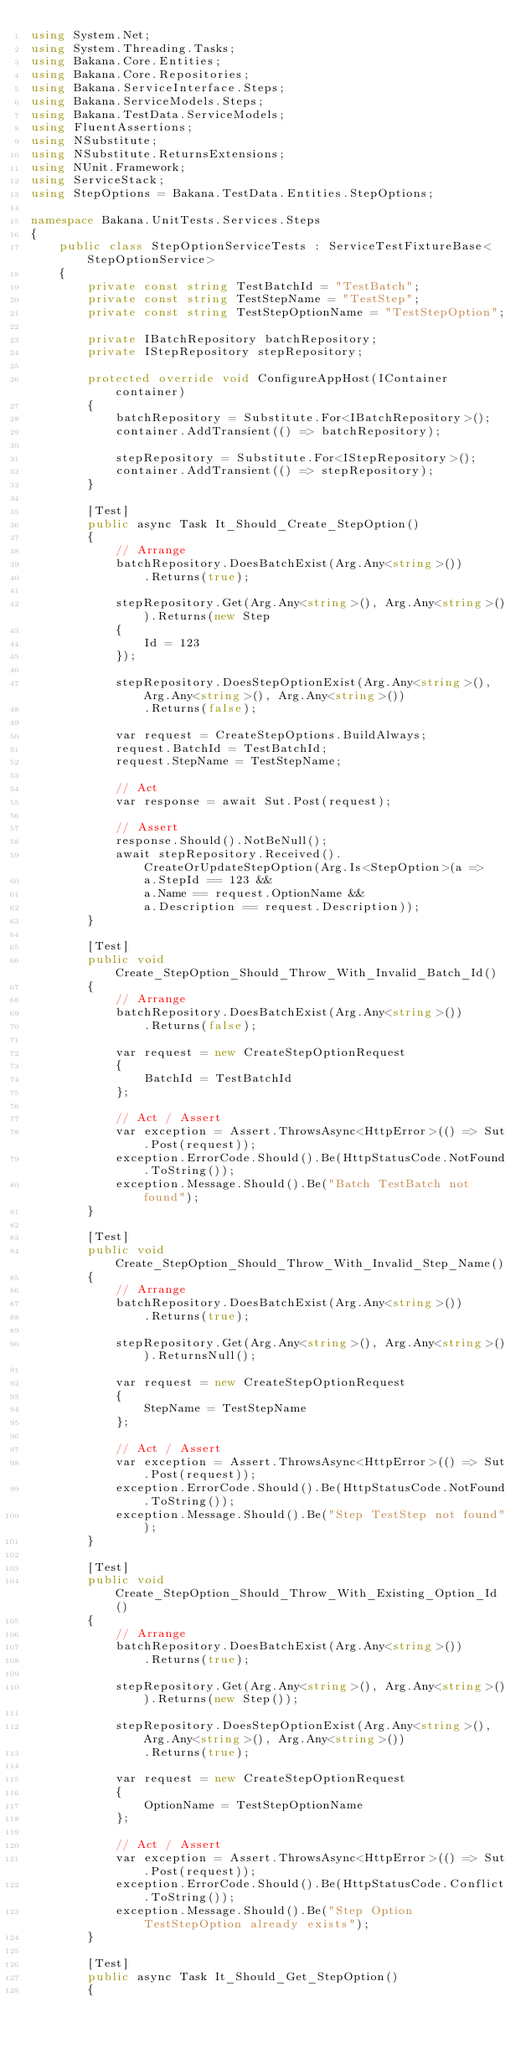Convert code to text. <code><loc_0><loc_0><loc_500><loc_500><_C#_>using System.Net;
using System.Threading.Tasks;
using Bakana.Core.Entities;
using Bakana.Core.Repositories;
using Bakana.ServiceInterface.Steps;
using Bakana.ServiceModels.Steps;
using Bakana.TestData.ServiceModels;
using FluentAssertions;
using NSubstitute;
using NSubstitute.ReturnsExtensions;
using NUnit.Framework;
using ServiceStack;
using StepOptions = Bakana.TestData.Entities.StepOptions;

namespace Bakana.UnitTests.Services.Steps
{
    public class StepOptionServiceTests : ServiceTestFixtureBase<StepOptionService>
    {
        private const string TestBatchId = "TestBatch";
        private const string TestStepName = "TestStep";
        private const string TestStepOptionName = "TestStepOption";
        
        private IBatchRepository batchRepository;
        private IStepRepository stepRepository;

        protected override void ConfigureAppHost(IContainer container)
        {
            batchRepository = Substitute.For<IBatchRepository>();
            container.AddTransient(() => batchRepository);

            stepRepository = Substitute.For<IStepRepository>();
            container.AddTransient(() => stepRepository);
        }
        
        [Test]
        public async Task It_Should_Create_StepOption()
        {
            // Arrange
            batchRepository.DoesBatchExist(Arg.Any<string>())
                .Returns(true);

            stepRepository.Get(Arg.Any<string>(), Arg.Any<string>()).Returns(new Step
            {
                Id = 123
            });
            
            stepRepository.DoesStepOptionExist(Arg.Any<string>(), Arg.Any<string>(), Arg.Any<string>())
                .Returns(false);
            
            var request = CreateStepOptions.BuildAlways;
            request.BatchId = TestBatchId;
            request.StepName = TestStepName;

            // Act
            var response = await Sut.Post(request);

            // Assert
            response.Should().NotBeNull();
            await stepRepository.Received().CreateOrUpdateStepOption(Arg.Is<StepOption>(a =>
                a.StepId == 123 &&
                a.Name == request.OptionName &&
                a.Description == request.Description));
        }

        [Test]
        public void Create_StepOption_Should_Throw_With_Invalid_Batch_Id()
        {
            // Arrange
            batchRepository.DoesBatchExist(Arg.Any<string>())
                .Returns(false);

            var request = new CreateStepOptionRequest
            {
                BatchId = TestBatchId
            };

            // Act / Assert
            var exception = Assert.ThrowsAsync<HttpError>(() => Sut.Post(request));
            exception.ErrorCode.Should().Be(HttpStatusCode.NotFound.ToString());
            exception.Message.Should().Be("Batch TestBatch not found");
        }

        [Test]
        public void Create_StepOption_Should_Throw_With_Invalid_Step_Name()
        {
            // Arrange
            batchRepository.DoesBatchExist(Arg.Any<string>())
                .Returns(true);

            stepRepository.Get(Arg.Any<string>(), Arg.Any<string>()).ReturnsNull();

            var request = new CreateStepOptionRequest
            {
                StepName = TestStepName
            };

            // Act / Assert
            var exception = Assert.ThrowsAsync<HttpError>(() => Sut.Post(request));
            exception.ErrorCode.Should().Be(HttpStatusCode.NotFound.ToString());
            exception.Message.Should().Be("Step TestStep not found");
        }

        [Test]
        public void Create_StepOption_Should_Throw_With_Existing_Option_Id()
        {
            // Arrange
            batchRepository.DoesBatchExist(Arg.Any<string>())
                .Returns(true);

            stepRepository.Get(Arg.Any<string>(), Arg.Any<string>()).Returns(new Step());

            stepRepository.DoesStepOptionExist(Arg.Any<string>(), Arg.Any<string>(), Arg.Any<string>())
                .Returns(true);

            var request = new CreateStepOptionRequest
            {
                OptionName = TestStepOptionName
            };

            // Act / Assert
            var exception = Assert.ThrowsAsync<HttpError>(() => Sut.Post(request));
            exception.ErrorCode.Should().Be(HttpStatusCode.Conflict.ToString());
            exception.Message.Should().Be("Step Option TestStepOption already exists");
        }
        
        [Test]
        public async Task It_Should_Get_StepOption()
        {</code> 